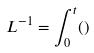Convert formula to latex. <formula><loc_0><loc_0><loc_500><loc_500>L ^ { - 1 } = \int _ { 0 } ^ { t } ( )</formula> 